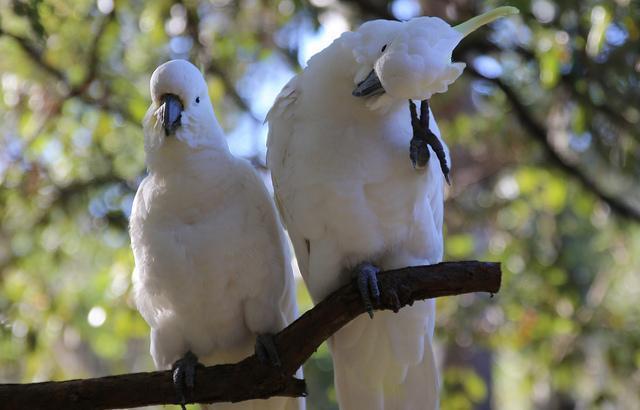How many birds are there?
Give a very brief answer. 2. How many birds can you see?
Give a very brief answer. 2. How many carrots are there?
Give a very brief answer. 0. 